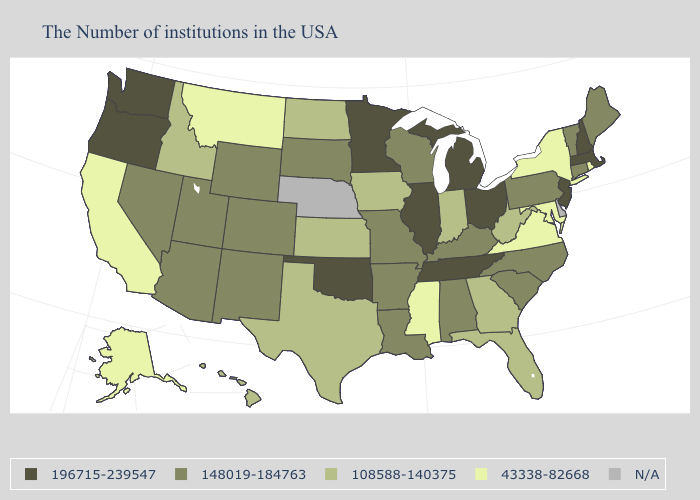Name the states that have a value in the range N/A?
Answer briefly. Delaware, Nebraska. What is the value of Florida?
Quick response, please. 108588-140375. Does Maryland have the highest value in the South?
Concise answer only. No. What is the value of Iowa?
Give a very brief answer. 108588-140375. Does the map have missing data?
Quick response, please. Yes. Name the states that have a value in the range N/A?
Answer briefly. Delaware, Nebraska. What is the highest value in the USA?
Answer briefly. 196715-239547. Among the states that border Tennessee , which have the lowest value?
Answer briefly. Virginia, Mississippi. What is the value of Maryland?
Keep it brief. 43338-82668. What is the highest value in states that border Rhode Island?
Concise answer only. 196715-239547. What is the value of Texas?
Write a very short answer. 108588-140375. Among the states that border Louisiana , which have the highest value?
Concise answer only. Arkansas. Which states hav the highest value in the West?
Answer briefly. Washington, Oregon. Which states have the lowest value in the USA?
Write a very short answer. Rhode Island, New York, Maryland, Virginia, Mississippi, Montana, California, Alaska. Does the map have missing data?
Be succinct. Yes. 